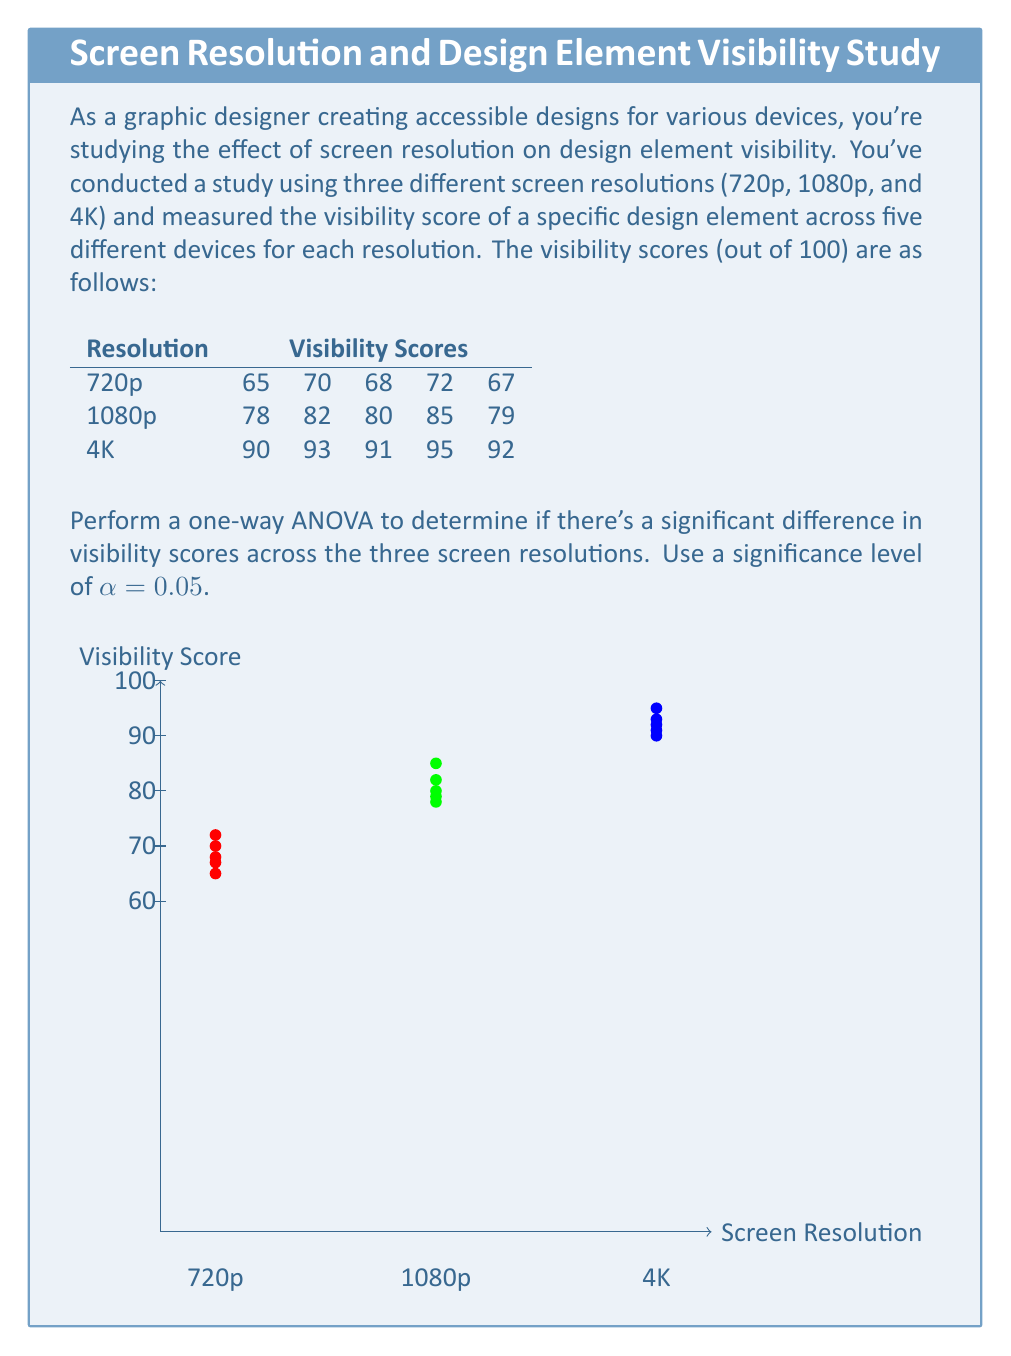Can you answer this question? Let's perform the one-way ANOVA step by step:

1) First, calculate the means for each group:
   720p: $\bar{X}_1 = \frac{65 + 70 + 68 + 72 + 67}{5} = 68.4$
   1080p: $\bar{X}_2 = \frac{78 + 82 + 80 + 85 + 79}{5} = 80.8$
   4K: $\bar{X}_3 = \frac{90 + 93 + 91 + 95 + 92}{5} = 92.2$

2) Calculate the grand mean:
   $\bar{X} = \frac{68.4 + 80.8 + 92.2}{3} = 80.47$

3) Calculate SSB (Sum of Squares Between groups):
   $SSB = 5[(68.4 - 80.47)^2 + (80.8 - 80.47)^2 + (92.2 - 80.47)^2] = 1789.63$

4) Calculate SSW (Sum of Squares Within groups):
   720p: $\sum(X - 68.4)^2 = 22.8$
   1080p: $\sum(X - 80.8)^2 = 30.8$
   4K: $\sum(X - 92.2)^2 = 14.8$
   $SSW = 22.8 + 30.8 + 14.8 = 68.4$

5) Calculate degrees of freedom:
   $df_{between} = k - 1 = 3 - 1 = 2$
   $df_{within} = N - k = 15 - 3 = 12$
   Where k is the number of groups and N is the total number of observations.

6) Calculate Mean Square Between (MSB) and Mean Square Within (MSW):
   $MSB = \frac{SSB}{df_{between}} = \frac{1789.63}{2} = 894.815$
   $MSW = \frac{SSW}{df_{within}} = \frac{68.4}{12} = 5.7$

7) Calculate the F-statistic:
   $F = \frac{MSB}{MSW} = \frac{894.815}{5.7} = 156.99$

8) Find the critical F-value:
   For $α = 0.05$, $df_{between} = 2$, and $df_{within} = 12$, the critical F-value is approximately 3.89.

9) Compare the F-statistic to the critical F-value:
   Since 156.99 > 3.89, we reject the null hypothesis.

10) Calculate the p-value:
    The p-value for F(2,12) = 156.99 is extremely small (p < 0.0001).
Answer: F(2,12) = 156.99, p < 0.0001. Significant difference in visibility scores across resolutions. 